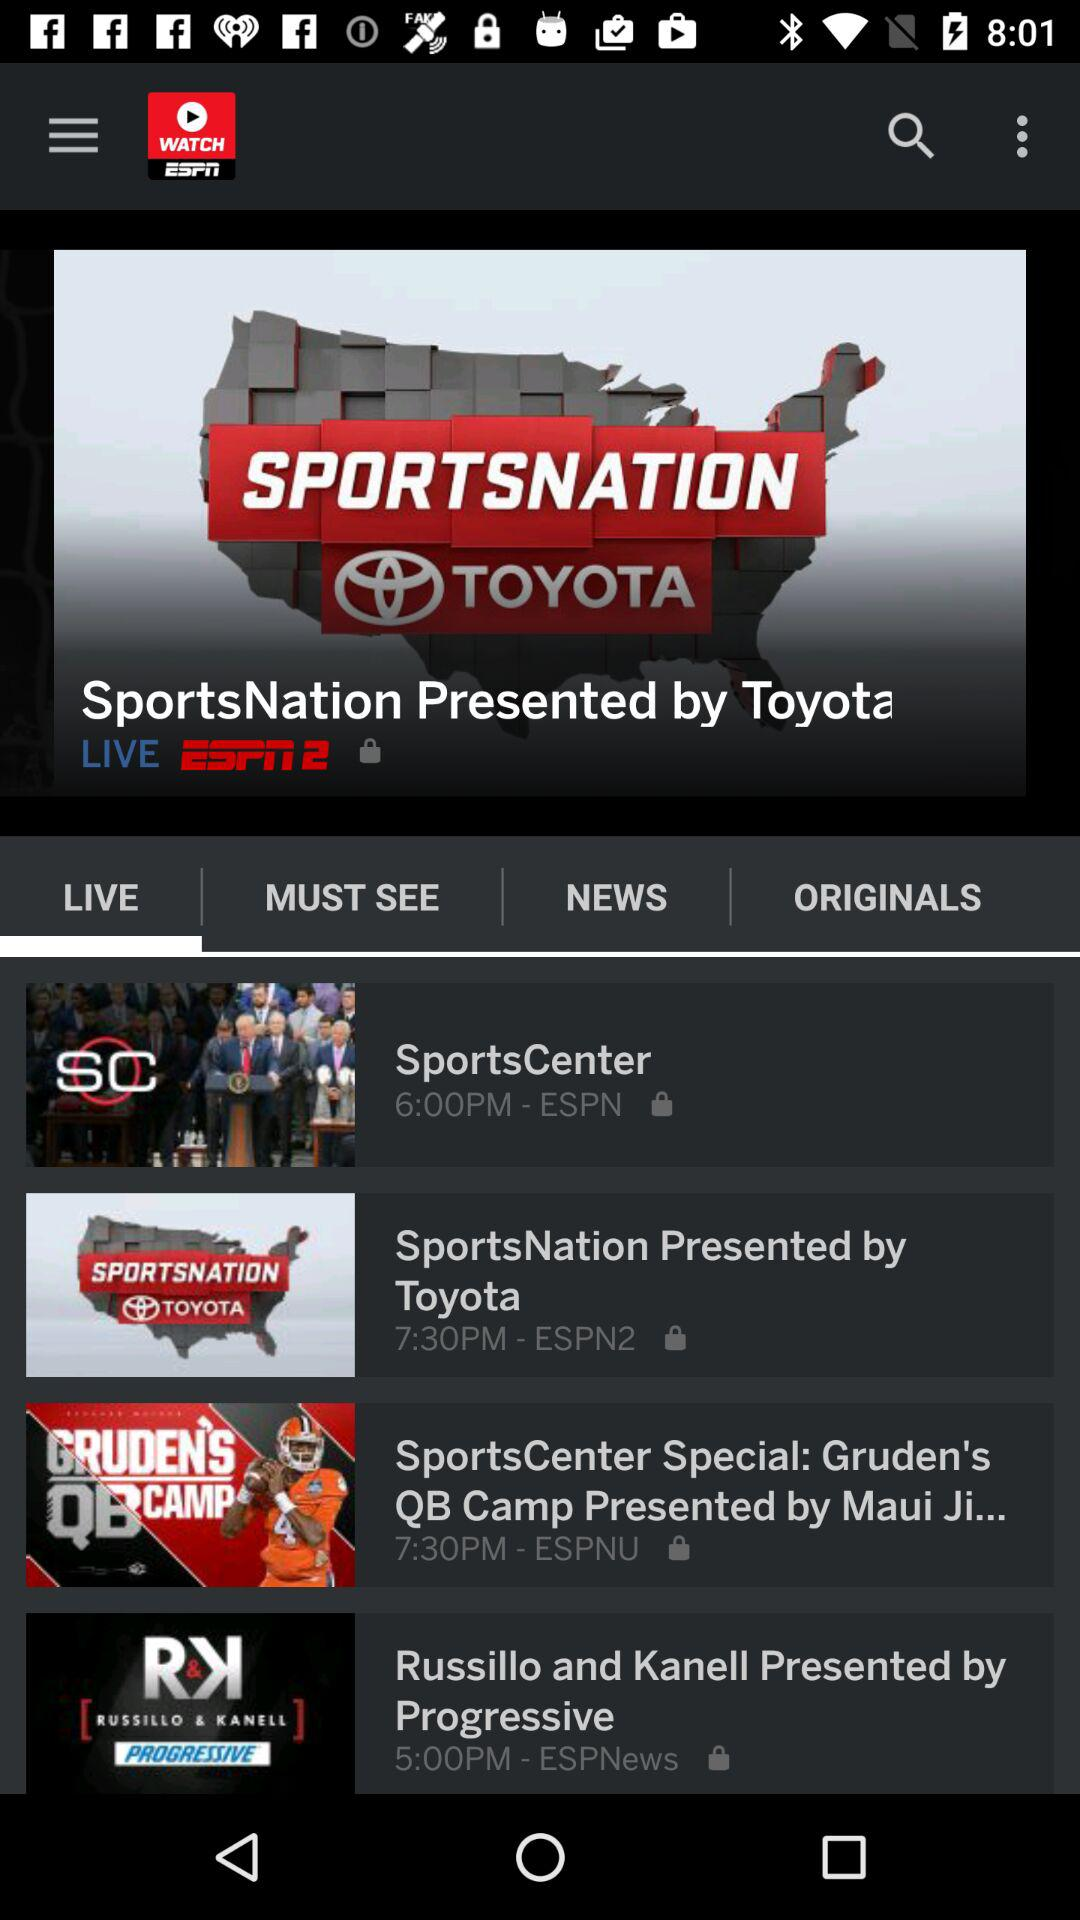What is the name of the channel that broadcasts "SportsCenter"? The name of the channel is "ESPN". 